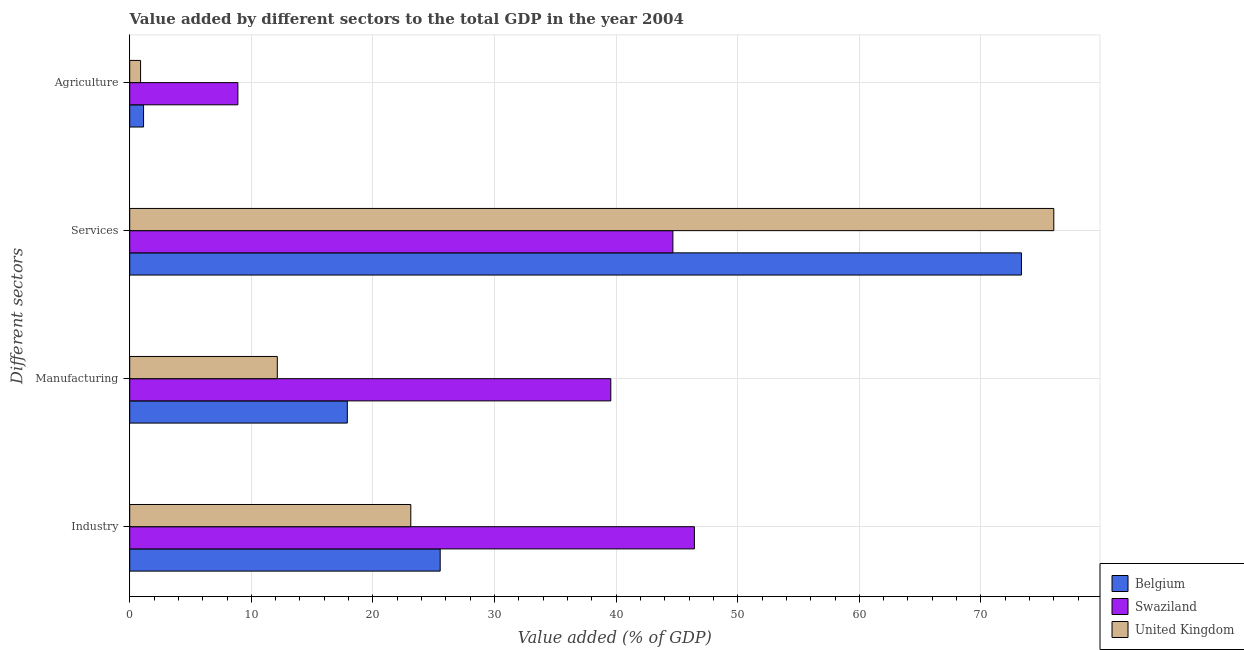How many different coloured bars are there?
Your response must be concise. 3. Are the number of bars on each tick of the Y-axis equal?
Offer a very short reply. Yes. How many bars are there on the 4th tick from the top?
Provide a short and direct response. 3. What is the label of the 2nd group of bars from the top?
Provide a succinct answer. Services. What is the value added by industrial sector in Swaziland?
Offer a terse response. 46.44. Across all countries, what is the maximum value added by manufacturing sector?
Provide a succinct answer. 39.56. Across all countries, what is the minimum value added by agricultural sector?
Make the answer very short. 0.89. In which country was the value added by agricultural sector maximum?
Offer a terse response. Swaziland. In which country was the value added by manufacturing sector minimum?
Your answer should be compact. United Kingdom. What is the total value added by agricultural sector in the graph?
Provide a succinct answer. 10.93. What is the difference between the value added by services sector in United Kingdom and that in Swaziland?
Provide a succinct answer. 31.32. What is the difference between the value added by industrial sector in Belgium and the value added by agricultural sector in United Kingdom?
Make the answer very short. 24.64. What is the average value added by agricultural sector per country?
Your response must be concise. 3.64. What is the difference between the value added by industrial sector and value added by agricultural sector in United Kingdom?
Provide a short and direct response. 22.22. What is the ratio of the value added by agricultural sector in United Kingdom to that in Belgium?
Your answer should be compact. 0.79. What is the difference between the highest and the second highest value added by industrial sector?
Ensure brevity in your answer.  20.9. What is the difference between the highest and the lowest value added by manufacturing sector?
Keep it short and to the point. 27.43. Is the sum of the value added by industrial sector in Swaziland and United Kingdom greater than the maximum value added by agricultural sector across all countries?
Provide a succinct answer. Yes. Is it the case that in every country, the sum of the value added by agricultural sector and value added by services sector is greater than the sum of value added by manufacturing sector and value added by industrial sector?
Provide a short and direct response. Yes. What does the 3rd bar from the bottom in Industry represents?
Give a very brief answer. United Kingdom. Is it the case that in every country, the sum of the value added by industrial sector and value added by manufacturing sector is greater than the value added by services sector?
Offer a terse response. No. How many bars are there?
Your answer should be very brief. 12. Are all the bars in the graph horizontal?
Provide a short and direct response. Yes. How many countries are there in the graph?
Ensure brevity in your answer.  3. Are the values on the major ticks of X-axis written in scientific E-notation?
Offer a very short reply. No. Does the graph contain grids?
Your answer should be very brief. Yes. Where does the legend appear in the graph?
Your response must be concise. Bottom right. How many legend labels are there?
Provide a succinct answer. 3. What is the title of the graph?
Your answer should be very brief. Value added by different sectors to the total GDP in the year 2004. Does "Botswana" appear as one of the legend labels in the graph?
Offer a very short reply. No. What is the label or title of the X-axis?
Offer a very short reply. Value added (% of GDP). What is the label or title of the Y-axis?
Your answer should be compact. Different sectors. What is the Value added (% of GDP) of Belgium in Industry?
Keep it short and to the point. 25.53. What is the Value added (% of GDP) of Swaziland in Industry?
Your answer should be very brief. 46.44. What is the Value added (% of GDP) in United Kingdom in Industry?
Give a very brief answer. 23.11. What is the Value added (% of GDP) in Belgium in Manufacturing?
Provide a succinct answer. 17.89. What is the Value added (% of GDP) of Swaziland in Manufacturing?
Give a very brief answer. 39.56. What is the Value added (% of GDP) in United Kingdom in Manufacturing?
Provide a succinct answer. 12.14. What is the Value added (% of GDP) of Belgium in Services?
Give a very brief answer. 73.33. What is the Value added (% of GDP) of Swaziland in Services?
Your response must be concise. 44.67. What is the Value added (% of GDP) of United Kingdom in Services?
Your answer should be compact. 75.99. What is the Value added (% of GDP) in Belgium in Agriculture?
Offer a terse response. 1.14. What is the Value added (% of GDP) in Swaziland in Agriculture?
Make the answer very short. 8.89. What is the Value added (% of GDP) in United Kingdom in Agriculture?
Your answer should be compact. 0.89. Across all Different sectors, what is the maximum Value added (% of GDP) in Belgium?
Your answer should be compact. 73.33. Across all Different sectors, what is the maximum Value added (% of GDP) in Swaziland?
Keep it short and to the point. 46.44. Across all Different sectors, what is the maximum Value added (% of GDP) of United Kingdom?
Your answer should be compact. 75.99. Across all Different sectors, what is the minimum Value added (% of GDP) of Belgium?
Your response must be concise. 1.14. Across all Different sectors, what is the minimum Value added (% of GDP) of Swaziland?
Your answer should be very brief. 8.89. Across all Different sectors, what is the minimum Value added (% of GDP) of United Kingdom?
Ensure brevity in your answer.  0.89. What is the total Value added (% of GDP) of Belgium in the graph?
Make the answer very short. 117.89. What is the total Value added (% of GDP) in Swaziland in the graph?
Offer a terse response. 139.56. What is the total Value added (% of GDP) of United Kingdom in the graph?
Offer a terse response. 112.14. What is the difference between the Value added (% of GDP) in Belgium in Industry and that in Manufacturing?
Provide a succinct answer. 7.64. What is the difference between the Value added (% of GDP) of Swaziland in Industry and that in Manufacturing?
Provide a succinct answer. 6.87. What is the difference between the Value added (% of GDP) of United Kingdom in Industry and that in Manufacturing?
Your answer should be compact. 10.98. What is the difference between the Value added (% of GDP) in Belgium in Industry and that in Services?
Offer a very short reply. -47.8. What is the difference between the Value added (% of GDP) in Swaziland in Industry and that in Services?
Give a very brief answer. 1.77. What is the difference between the Value added (% of GDP) of United Kingdom in Industry and that in Services?
Provide a succinct answer. -52.88. What is the difference between the Value added (% of GDP) in Belgium in Industry and that in Agriculture?
Provide a short and direct response. 24.39. What is the difference between the Value added (% of GDP) in Swaziland in Industry and that in Agriculture?
Make the answer very short. 37.54. What is the difference between the Value added (% of GDP) of United Kingdom in Industry and that in Agriculture?
Offer a terse response. 22.22. What is the difference between the Value added (% of GDP) of Belgium in Manufacturing and that in Services?
Make the answer very short. -55.44. What is the difference between the Value added (% of GDP) of Swaziland in Manufacturing and that in Services?
Your answer should be compact. -5.11. What is the difference between the Value added (% of GDP) in United Kingdom in Manufacturing and that in Services?
Your response must be concise. -63.86. What is the difference between the Value added (% of GDP) of Belgium in Manufacturing and that in Agriculture?
Your answer should be compact. 16.76. What is the difference between the Value added (% of GDP) in Swaziland in Manufacturing and that in Agriculture?
Your answer should be compact. 30.67. What is the difference between the Value added (% of GDP) in United Kingdom in Manufacturing and that in Agriculture?
Provide a short and direct response. 11.24. What is the difference between the Value added (% of GDP) in Belgium in Services and that in Agriculture?
Ensure brevity in your answer.  72.19. What is the difference between the Value added (% of GDP) in Swaziland in Services and that in Agriculture?
Your answer should be very brief. 35.77. What is the difference between the Value added (% of GDP) in United Kingdom in Services and that in Agriculture?
Provide a short and direct response. 75.1. What is the difference between the Value added (% of GDP) in Belgium in Industry and the Value added (% of GDP) in Swaziland in Manufacturing?
Make the answer very short. -14.03. What is the difference between the Value added (% of GDP) of Belgium in Industry and the Value added (% of GDP) of United Kingdom in Manufacturing?
Give a very brief answer. 13.4. What is the difference between the Value added (% of GDP) of Swaziland in Industry and the Value added (% of GDP) of United Kingdom in Manufacturing?
Ensure brevity in your answer.  34.3. What is the difference between the Value added (% of GDP) in Belgium in Industry and the Value added (% of GDP) in Swaziland in Services?
Make the answer very short. -19.14. What is the difference between the Value added (% of GDP) in Belgium in Industry and the Value added (% of GDP) in United Kingdom in Services?
Your answer should be very brief. -50.46. What is the difference between the Value added (% of GDP) in Swaziland in Industry and the Value added (% of GDP) in United Kingdom in Services?
Make the answer very short. -29.56. What is the difference between the Value added (% of GDP) of Belgium in Industry and the Value added (% of GDP) of Swaziland in Agriculture?
Offer a terse response. 16.64. What is the difference between the Value added (% of GDP) in Belgium in Industry and the Value added (% of GDP) in United Kingdom in Agriculture?
Provide a succinct answer. 24.64. What is the difference between the Value added (% of GDP) in Swaziland in Industry and the Value added (% of GDP) in United Kingdom in Agriculture?
Keep it short and to the point. 45.54. What is the difference between the Value added (% of GDP) in Belgium in Manufacturing and the Value added (% of GDP) in Swaziland in Services?
Provide a short and direct response. -26.77. What is the difference between the Value added (% of GDP) in Belgium in Manufacturing and the Value added (% of GDP) in United Kingdom in Services?
Offer a terse response. -58.1. What is the difference between the Value added (% of GDP) in Swaziland in Manufacturing and the Value added (% of GDP) in United Kingdom in Services?
Your response must be concise. -36.43. What is the difference between the Value added (% of GDP) of Belgium in Manufacturing and the Value added (% of GDP) of Swaziland in Agriculture?
Ensure brevity in your answer.  9. What is the difference between the Value added (% of GDP) in Belgium in Manufacturing and the Value added (% of GDP) in United Kingdom in Agriculture?
Your response must be concise. 17. What is the difference between the Value added (% of GDP) of Swaziland in Manufacturing and the Value added (% of GDP) of United Kingdom in Agriculture?
Your response must be concise. 38.67. What is the difference between the Value added (% of GDP) in Belgium in Services and the Value added (% of GDP) in Swaziland in Agriculture?
Provide a succinct answer. 64.44. What is the difference between the Value added (% of GDP) of Belgium in Services and the Value added (% of GDP) of United Kingdom in Agriculture?
Provide a succinct answer. 72.44. What is the difference between the Value added (% of GDP) of Swaziland in Services and the Value added (% of GDP) of United Kingdom in Agriculture?
Your response must be concise. 43.78. What is the average Value added (% of GDP) in Belgium per Different sectors?
Provide a short and direct response. 29.47. What is the average Value added (% of GDP) in Swaziland per Different sectors?
Your response must be concise. 34.89. What is the average Value added (% of GDP) of United Kingdom per Different sectors?
Offer a terse response. 28.03. What is the difference between the Value added (% of GDP) in Belgium and Value added (% of GDP) in Swaziland in Industry?
Ensure brevity in your answer.  -20.9. What is the difference between the Value added (% of GDP) in Belgium and Value added (% of GDP) in United Kingdom in Industry?
Your answer should be very brief. 2.42. What is the difference between the Value added (% of GDP) in Swaziland and Value added (% of GDP) in United Kingdom in Industry?
Provide a short and direct response. 23.32. What is the difference between the Value added (% of GDP) of Belgium and Value added (% of GDP) of Swaziland in Manufacturing?
Provide a short and direct response. -21.67. What is the difference between the Value added (% of GDP) of Belgium and Value added (% of GDP) of United Kingdom in Manufacturing?
Give a very brief answer. 5.76. What is the difference between the Value added (% of GDP) of Swaziland and Value added (% of GDP) of United Kingdom in Manufacturing?
Keep it short and to the point. 27.43. What is the difference between the Value added (% of GDP) in Belgium and Value added (% of GDP) in Swaziland in Services?
Provide a succinct answer. 28.66. What is the difference between the Value added (% of GDP) of Belgium and Value added (% of GDP) of United Kingdom in Services?
Your response must be concise. -2.66. What is the difference between the Value added (% of GDP) of Swaziland and Value added (% of GDP) of United Kingdom in Services?
Keep it short and to the point. -31.32. What is the difference between the Value added (% of GDP) of Belgium and Value added (% of GDP) of Swaziland in Agriculture?
Provide a succinct answer. -7.76. What is the difference between the Value added (% of GDP) of Belgium and Value added (% of GDP) of United Kingdom in Agriculture?
Your response must be concise. 0.24. What is the difference between the Value added (% of GDP) of Swaziland and Value added (% of GDP) of United Kingdom in Agriculture?
Offer a terse response. 8. What is the ratio of the Value added (% of GDP) in Belgium in Industry to that in Manufacturing?
Keep it short and to the point. 1.43. What is the ratio of the Value added (% of GDP) of Swaziland in Industry to that in Manufacturing?
Your answer should be compact. 1.17. What is the ratio of the Value added (% of GDP) in United Kingdom in Industry to that in Manufacturing?
Offer a very short reply. 1.9. What is the ratio of the Value added (% of GDP) in Belgium in Industry to that in Services?
Your answer should be compact. 0.35. What is the ratio of the Value added (% of GDP) in Swaziland in Industry to that in Services?
Make the answer very short. 1.04. What is the ratio of the Value added (% of GDP) of United Kingdom in Industry to that in Services?
Offer a very short reply. 0.3. What is the ratio of the Value added (% of GDP) in Belgium in Industry to that in Agriculture?
Offer a very short reply. 22.45. What is the ratio of the Value added (% of GDP) in Swaziland in Industry to that in Agriculture?
Provide a short and direct response. 5.22. What is the ratio of the Value added (% of GDP) in United Kingdom in Industry to that in Agriculture?
Your answer should be very brief. 25.89. What is the ratio of the Value added (% of GDP) of Belgium in Manufacturing to that in Services?
Your answer should be very brief. 0.24. What is the ratio of the Value added (% of GDP) in Swaziland in Manufacturing to that in Services?
Offer a very short reply. 0.89. What is the ratio of the Value added (% of GDP) in United Kingdom in Manufacturing to that in Services?
Ensure brevity in your answer.  0.16. What is the ratio of the Value added (% of GDP) in Belgium in Manufacturing to that in Agriculture?
Provide a short and direct response. 15.73. What is the ratio of the Value added (% of GDP) in Swaziland in Manufacturing to that in Agriculture?
Ensure brevity in your answer.  4.45. What is the ratio of the Value added (% of GDP) in United Kingdom in Manufacturing to that in Agriculture?
Ensure brevity in your answer.  13.59. What is the ratio of the Value added (% of GDP) of Belgium in Services to that in Agriculture?
Offer a very short reply. 64.48. What is the ratio of the Value added (% of GDP) in Swaziland in Services to that in Agriculture?
Offer a terse response. 5.02. What is the ratio of the Value added (% of GDP) in United Kingdom in Services to that in Agriculture?
Provide a succinct answer. 85.11. What is the difference between the highest and the second highest Value added (% of GDP) in Belgium?
Keep it short and to the point. 47.8. What is the difference between the highest and the second highest Value added (% of GDP) in Swaziland?
Offer a terse response. 1.77. What is the difference between the highest and the second highest Value added (% of GDP) in United Kingdom?
Your response must be concise. 52.88. What is the difference between the highest and the lowest Value added (% of GDP) in Belgium?
Offer a terse response. 72.19. What is the difference between the highest and the lowest Value added (% of GDP) of Swaziland?
Provide a short and direct response. 37.54. What is the difference between the highest and the lowest Value added (% of GDP) in United Kingdom?
Your answer should be very brief. 75.1. 